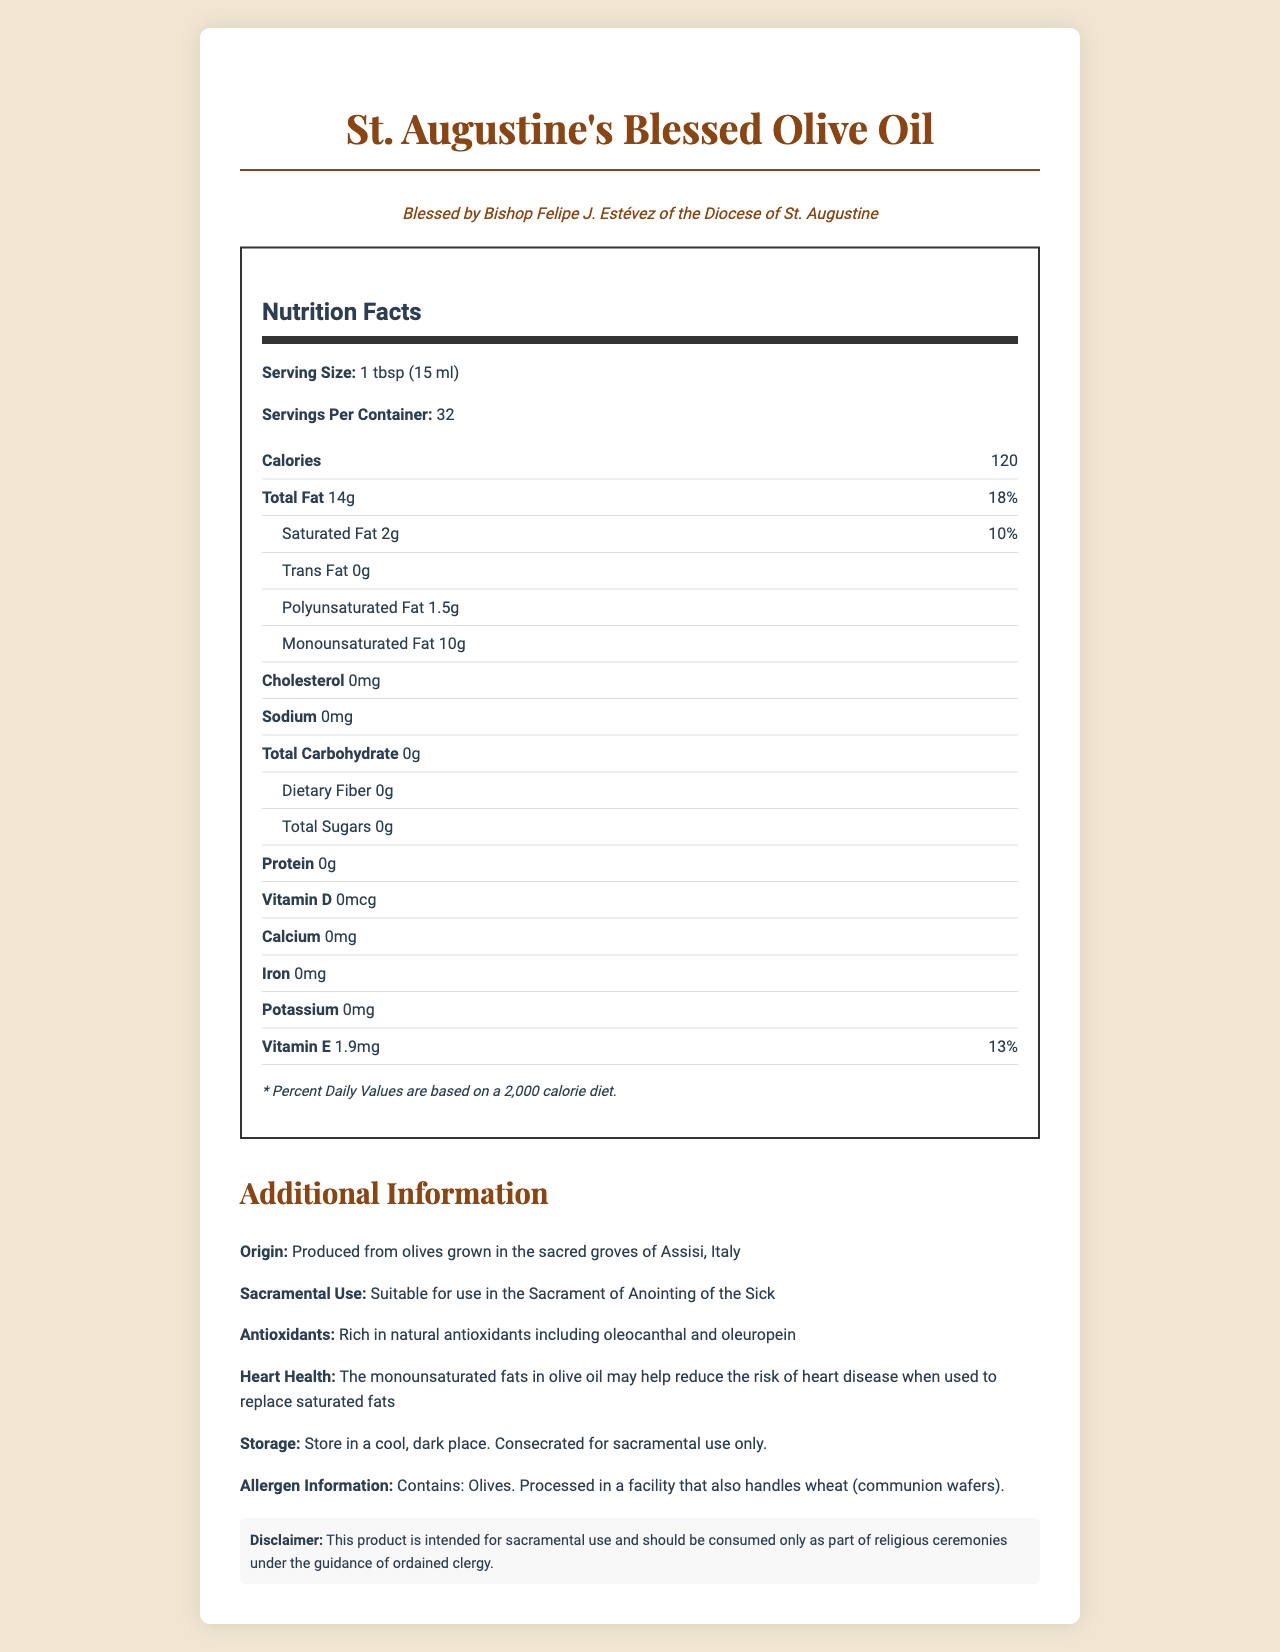what is the product name? The product name is stated at the top of the document and in the heading: "St. Augustine's Blessed Olive Oil."
Answer: St. Augustine's Blessed Olive Oil how many calories are in one serving? The document states under the Nutrition Facts section: "Calories 120."
Answer: 120 how much monounsaturated fat is in one serving? The document lists "Monounsaturated Fat 10g" under the nutrition label.
Answer: 10g what is the serving size? The serving size is found under the Nutrition Facts section: "Serving Size: 1 tbsp (15 ml)."
Answer: 1 tbsp (15 ml) what is the daily value percentage of total fat per serving? The daily value for total fat, indicated in the document, is "18%."
Answer: 18% which ingredients give St. Augustine's Blessed Olive Oil its antioxidant properties? A. Oleocanthal and Oleuropein B. Vitamin C and Zinc C. Beta-Carotene and Lycopene The antioxidant information section lists oleocanthal and oleuropein as the natural antioxidants.
Answer: A what percentage of oleic acid does the olive oil contain? The document states: "Oleic Acid: 73%."
Answer: 73% who blessed the St. Augustine's Blessed Olive Oil? A. Pope John Paul II B. Bishop Robert Barron C. Bishop Felipe J. Estévez D. Cardinal Timothy Dolan The document states: "Blessed by Bishop Felipe J. Estévez."
Answer: C is the olive oil suitable for use in the Sacrament of Anointing of the Sick? The document confirms this in the section "Sacramental Use: Suitable for use in the Sacrament of Anointing of the Sick."
Answer: Yes what do the storage instructions recommend? The storage instructions explicitly state: "Store in a cool, dark place. Consecrated for sacramental use only."
Answer: Store in a cool, dark place. Consecrated for sacramental use only. how many servings are there per container? The document states under the Nutrition Facts section: "Servings Per Container: 32."
Answer: 32 what vitamin does the olive oil contain and how much of it per serving? The nutrition label lists "Vitamin E 1.9mg" with a daily value of 13%.
Answer: Vitamin E, 1.9mg describe the main idea of this document. The document serves as an informative guide outlining the nutritional content and sacramental significance of the olive oil, highlighting its health benefits and usage instructions.
Answer: The document provides detailed information about St. Augustine's Blessed Olive Oil, including its nutritional facts, origin, sacramental use, and the blessing by Bishop Felipe J. Estévez. It emphasizes the health benefits, particularly the high content of monounsaturated fats and natural antioxidants. The document also includes serving sizes, storage instructions, and allergen information. how much iron does the olive oil have? The nutrition label lists "Iron: 0mg."
Answer: 0mg where are the olives used to produce this olive oil grown? The document states: "Produced from olives grown in the sacred groves of Assisi, Italy."
Answer: Assisi, Italy can I use St. Augustine's Blessed Olive Oil for cooking? The document mentions that it is consecrated for sacramental use only and does not provide information on whether it can be used for cooking.
Answer: Not enough information what is the polyphenol content per serving? The document highlights: "polyphenols: 30mg."
Answer: 30mg 